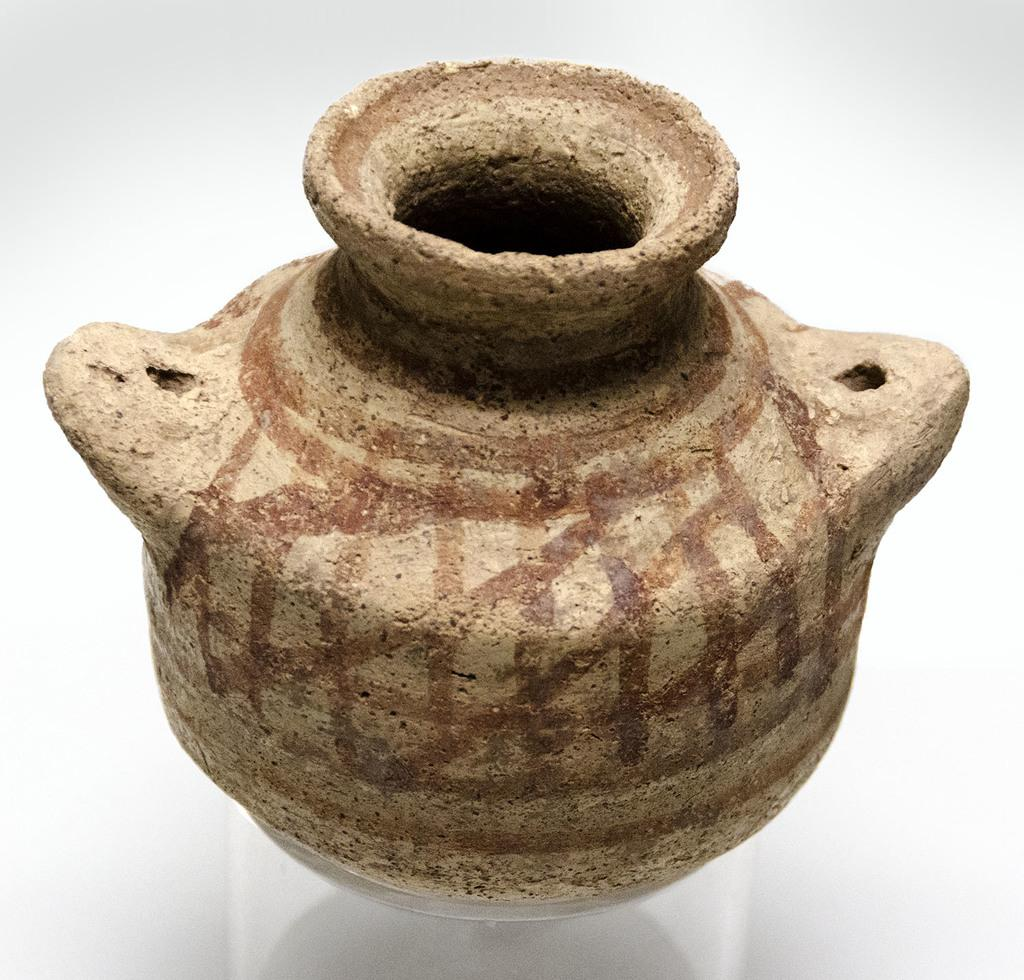What object is the main focus of the image? There is a pot in the image. What is the color of the pot? The pot is brown in color. What is the pot placed on in the image? The pot is on a white surface. What type of guitar is being played quietly in the image? There is no guitar or indication of sound in the image; it only features a brown pot on a white surface. 